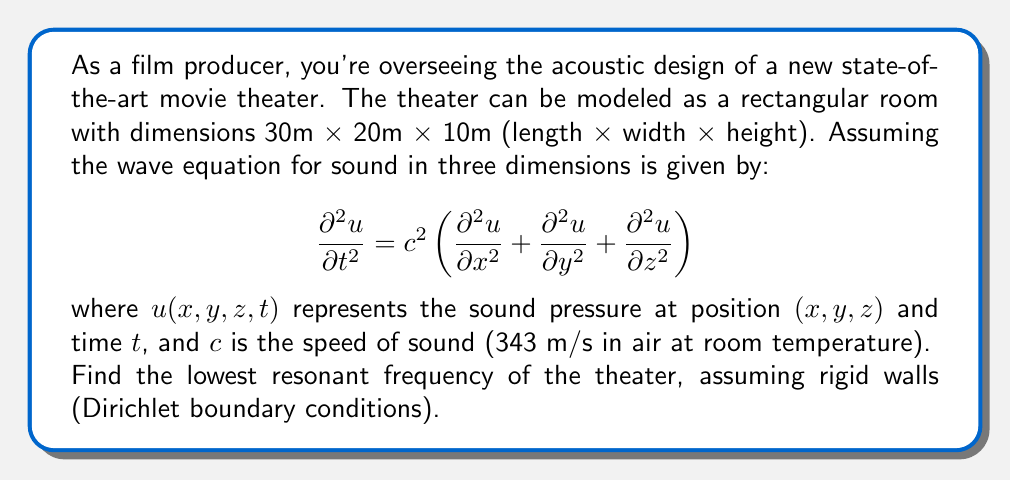Solve this math problem. To solve this problem, we need to follow these steps:

1) For a rectangular room with rigid walls, the solution to the wave equation takes the form:

   $$ u(x,y,z,t) = \sin(\frac{n_x\pi x}{L_x}) \sin(\frac{n_y\pi y}{L_y}) \sin(\frac{n_z\pi z}{L_z}) \cos(\omega t) $$

   where $L_x$, $L_y$, and $L_z$ are the dimensions of the room, and $n_x$, $n_y$, and $n_z$ are positive integers.

2) The angular frequency $\omega$ is related to these parameters by:

   $$ \omega^2 = c^2\pi^2\left(\frac{n_x^2}{L_x^2} + \frac{n_y^2}{L_y^2} + \frac{n_z^2}{L_z^2}\right) $$

3) The lowest resonant frequency occurs when $n_x = 1$, $n_y = 1$, and $n_z = 1$. Substituting these values and the given dimensions:

   $$ \omega^2 = c^2\pi^2\left(\frac{1^2}{30^2} + \frac{1^2}{20^2} + \frac{1^2}{10^2}\right) $$

4) Simplify:
   $$ \omega^2 = (343^2)\pi^2\left(\frac{1}{900} + \frac{1}{400} + \frac{1}{100}\right) $$
   $$ \omega^2 = 117649\pi^2(0.001111 + 0.0025 + 0.01) $$
   $$ \omega^2 = 117649\pi^2(0.013611) $$
   $$ \omega^2 = 5021.95 $$

5) Take the square root:
   $$ \omega = \sqrt{5021.95} = 70.86 \text{ rad/s} $$

6) Convert angular frequency to frequency:
   $$ f = \frac{\omega}{2\pi} = \frac{70.86}{2\pi} = 11.28 \text{ Hz} $$

Therefore, the lowest resonant frequency of the theater is approximately 11.28 Hz.
Answer: 11.28 Hz 